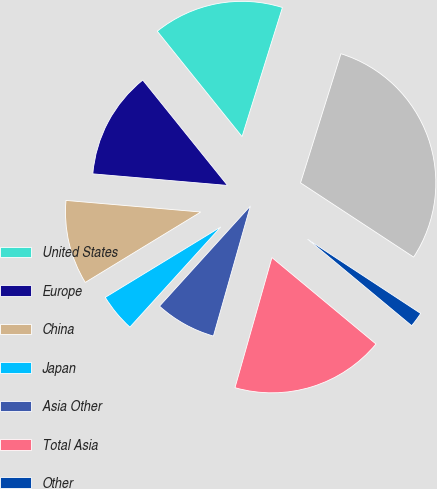Convert chart. <chart><loc_0><loc_0><loc_500><loc_500><pie_chart><fcel>United States<fcel>Europe<fcel>China<fcel>Japan<fcel>Asia Other<fcel>Total Asia<fcel>Other<fcel>Total net sales<nl><fcel>15.61%<fcel>12.85%<fcel>10.08%<fcel>4.56%<fcel>7.32%<fcel>18.37%<fcel>1.79%<fcel>29.42%<nl></chart> 